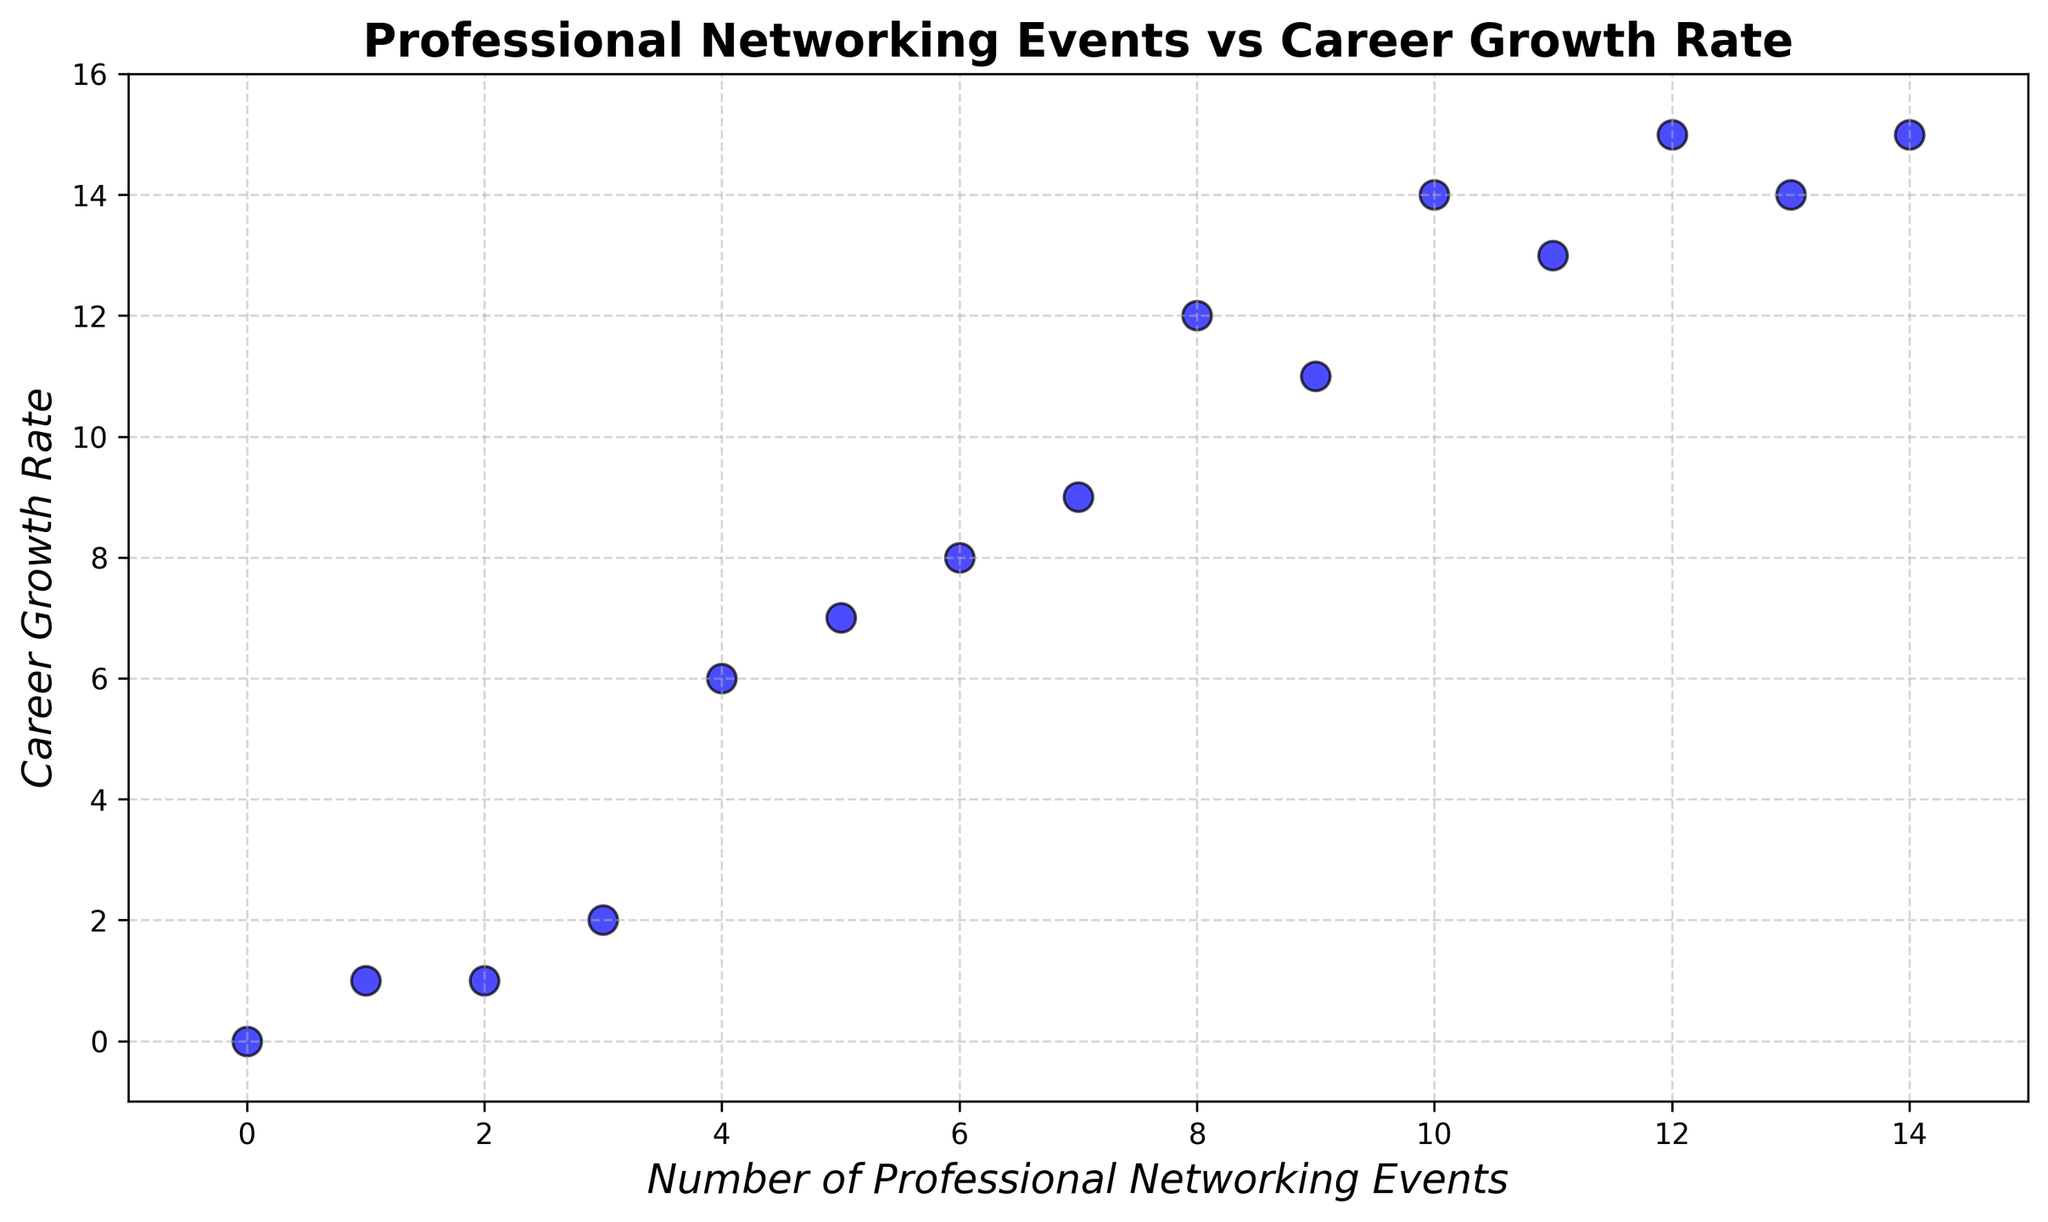How many data points are there in the plot? Count the total number of points present in the scatter plot. By counting each individual point, you can see that there are 15 data points in the plot.
Answer: 15 What is the maximum number of professional networking events attended by a professional in this data? Identify the highest value along the x-axis (Number of Professional Networking Events). The maximum number is 14.
Answer: 14 Which data point has the highest career growth rate and how many networking events did that professional attend? Look for the data point with the highest value on the y-axis (Career Growth Rate). Identify the corresponding x-axis value. The highest career growth rate is 15, which corresponds to 12, 13, and 14 networking events.
Answer: 12, 13, and 14 Is there an outlier in the data set? Check for any points significantly distant from other data points. Here, (0, 0) stands out because all other points have much higher values of professional networking events and career growth rates.
Answer: (0, 0) What's the average career growth rate for professionals attending more than 10 networking events? Identify the career growth rates for professionals attending more than 10 events: These are points (12, 15), (11, 13), (13, 14), and (14, 15). Sum these values (15 + 13 + 14 + 15 = 57) and divide by the number of points (57 / 4 = 14.25).
Answer: 14.25 How many professionals have a single-digit career growth rate? Count the number of data points with a y-value (Career Growth Rate) less than 10. The points are (3, 2), (5, 7), (8, 12), (10, 14), (2, 1), (6, 8), (4, 6), (9, 11), (7, 9), (1, 1), (0, 0). The single-digit career growth rates are at points (3, 2), (5, 7), (2, 1), (6, 8), (4, 6), (7, 9), (1, 1), and (0, 0)—8 points in total.
Answer: 8 What is the correlation between professional networking events and career growth rate? Observe the trend depicted by the scatter plot. The data points generally show an upward trend, indicating a positive correlation between the number of networking events attended and career growth rate.
Answer: Positive Between attending 5 and 10 networking events, what is the range of career growth rates observed? Identify data points where the x-values are between 5 and 10. These are points (5, 7), (8, 12), (10, 14), (6, 8), (9, 11), and (7, 9). The career growth rates (y-values) for these are 7, 12, 14, 8, 11, and 9. The range is the difference between the max (14) and min (7) values, which is 14 - 7 = 7.
Answer: 7 Which appears to grow more steeply: career growth rate from 5 to 10 events, or from 10 to 15 events? Compare the slope of the lines drawn between the points from (5, 7) to (10, 14) and from (10, 14) to (15, 15). The slope for the former is (14 - 7) / (10 - 5) = 7 / 5 = 1.4. The career growth rate from 10 to 15 events increases by only 1 unit while the number of events increases by 5. Hence, the career growth rate grows less steeply from 10 to 15 events.
Answer: 5 to 10 